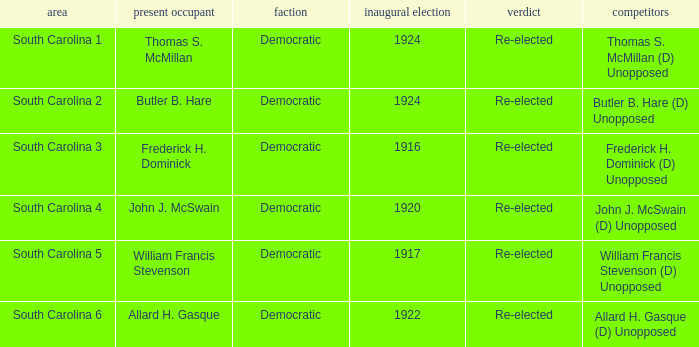What year was william francis stevenson first elected? 1917.0. 